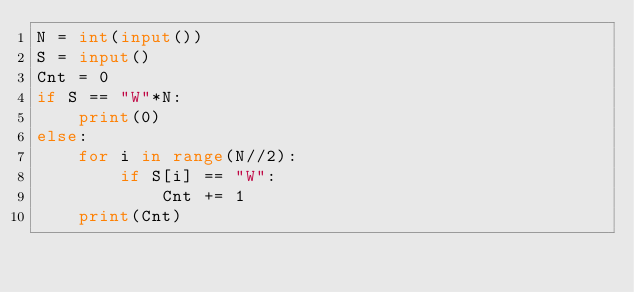Convert code to text. <code><loc_0><loc_0><loc_500><loc_500><_Python_>N = int(input())
S = input()
Cnt = 0
if S == "W"*N:
    print(0)
else:
    for i in range(N//2):
        if S[i] == "W":
            Cnt += 1
    print(Cnt)</code> 